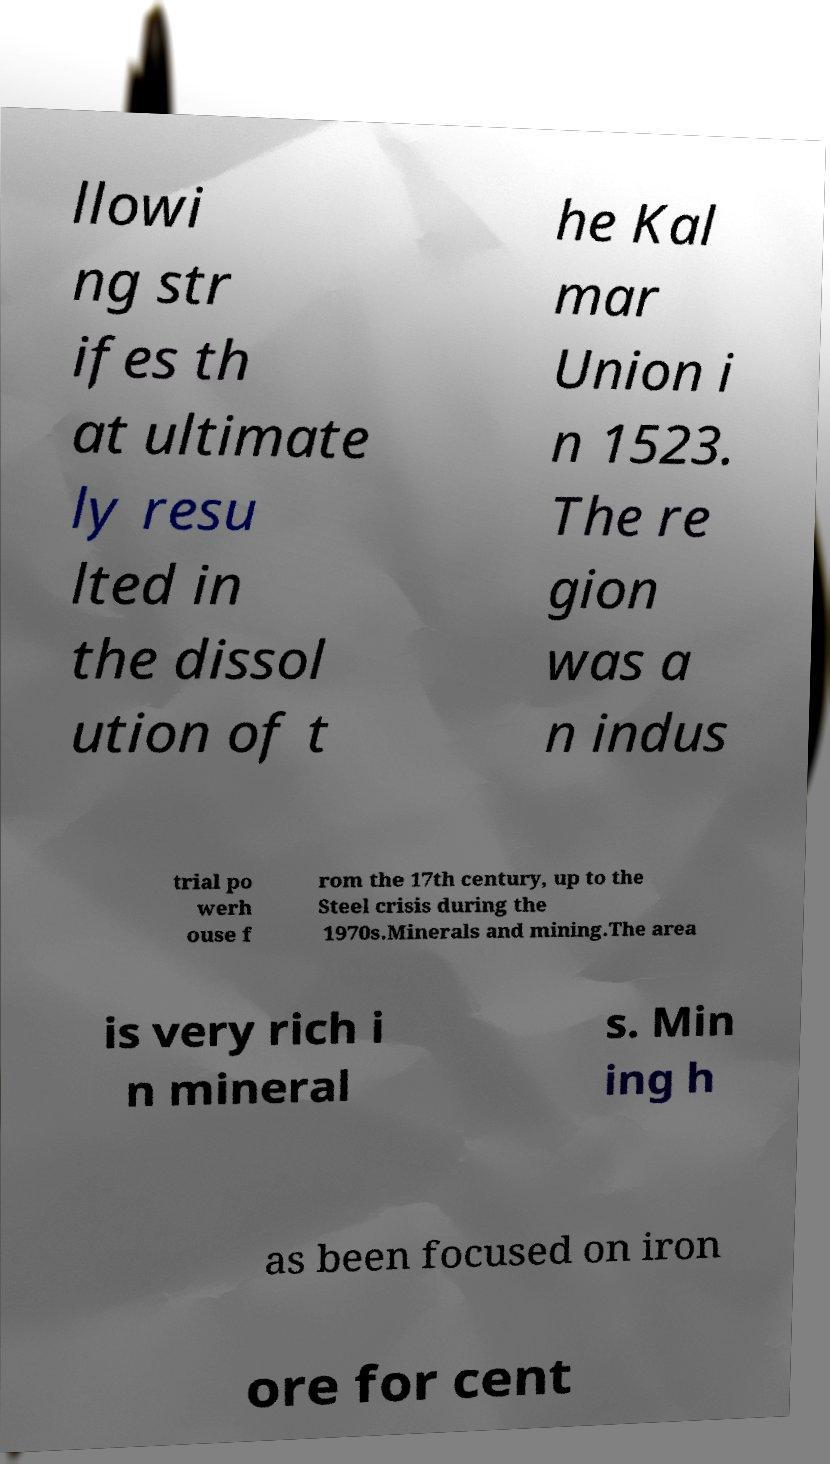Could you assist in decoding the text presented in this image and type it out clearly? llowi ng str ifes th at ultimate ly resu lted in the dissol ution of t he Kal mar Union i n 1523. The re gion was a n indus trial po werh ouse f rom the 17th century, up to the Steel crisis during the 1970s.Minerals and mining.The area is very rich i n mineral s. Min ing h as been focused on iron ore for cent 